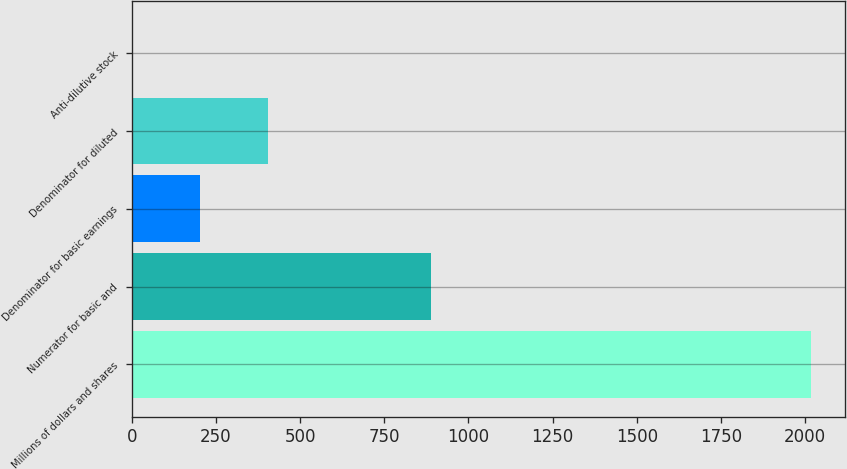Convert chart to OTSL. <chart><loc_0><loc_0><loc_500><loc_500><bar_chart><fcel>Millions of dollars and shares<fcel>Numerator for basic and<fcel>Denominator for basic earnings<fcel>Denominator for diluted<fcel>Anti-dilutive stock<nl><fcel>2016<fcel>888<fcel>201.87<fcel>403.44<fcel>0.3<nl></chart> 